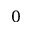<formula> <loc_0><loc_0><loc_500><loc_500>0</formula> 